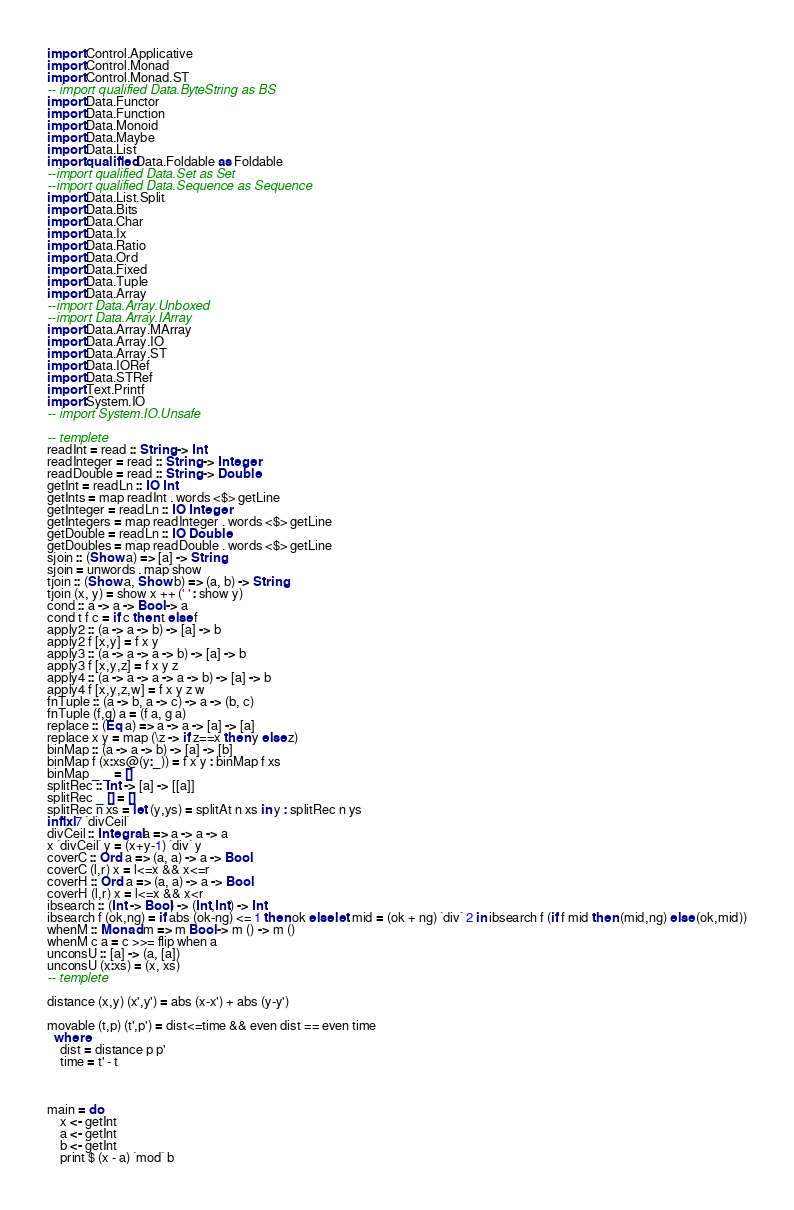<code> <loc_0><loc_0><loc_500><loc_500><_Haskell_>import Control.Applicative
import Control.Monad
import Control.Monad.ST
-- import qualified Data.ByteString as BS
import Data.Functor
import Data.Function
import Data.Monoid
import Data.Maybe
import Data.List
import qualified Data.Foldable as Foldable
--import qualified Data.Set as Set
--import qualified Data.Sequence as Sequence
import Data.List.Split
import Data.Bits
import Data.Char
import Data.Ix
import Data.Ratio
import Data.Ord
import Data.Fixed
import Data.Tuple
import Data.Array
--import Data.Array.Unboxed
--import Data.Array.IArray
import Data.Array.MArray
import Data.Array.IO
import Data.Array.ST
import Data.IORef
import Data.STRef
import Text.Printf
import System.IO
-- import System.IO.Unsafe
 
-- templete
readInt = read :: String -> Int
readInteger = read :: String -> Integer
readDouble = read :: String -> Double
getInt = readLn :: IO Int
getInts = map readInt . words <$> getLine
getInteger = readLn :: IO Integer
getIntegers = map readInteger . words <$> getLine
getDouble = readLn :: IO Double
getDoubles = map readDouble . words <$> getLine
sjoin :: (Show a) => [a] -> String
sjoin = unwords . map show
tjoin :: (Show a, Show b) => (a, b) -> String
tjoin (x, y) = show x ++ (' ' : show y)
cond :: a -> a -> Bool -> a
cond t f c = if c then t else f
apply2 :: (a -> a -> b) -> [a] -> b
apply2 f [x,y] = f x y
apply3 :: (a -> a -> a -> b) -> [a] -> b
apply3 f [x,y,z] = f x y z
apply4 :: (a -> a -> a -> a -> b) -> [a] -> b
apply4 f [x,y,z,w] = f x y z w
fnTuple :: (a -> b, a -> c) -> a -> (b, c)
fnTuple (f,g) a = (f a, g a)
replace :: (Eq a) => a -> a -> [a] -> [a]
replace x y = map (\z -> if z==x then y else z)
binMap :: (a -> a -> b) -> [a] -> [b]
binMap f (x:xs@(y:_)) = f x y : binMap f xs
binMap _ _ = []
splitRec :: Int -> [a] -> [[a]]
splitRec _ [] = []
splitRec n xs = let (y,ys) = splitAt n xs in y : splitRec n ys
infixl 7 `divCeil`
divCeil :: Integral a => a -> a -> a
x `divCeil` y = (x+y-1) `div` y
coverC :: Ord a => (a, a) -> a -> Bool
coverC (l,r) x = l<=x && x<=r
coverH :: Ord a => (a, a) -> a -> Bool
coverH (l,r) x = l<=x && x<r
ibsearch :: (Int -> Bool) -> (Int,Int) -> Int
ibsearch f (ok,ng) = if abs (ok-ng) <= 1 then ok else let mid = (ok + ng) `div` 2 in ibsearch f (if f mid then (mid,ng) else (ok,mid))
whenM :: Monad m => m Bool -> m () -> m ()
whenM c a = c >>= flip when a
unconsU :: [a] -> (a, [a])
unconsU (x:xs) = (x, xs)
-- templete

distance (x,y) (x',y') = abs (x-x') + abs (y-y')

movable (t,p) (t',p') = dist<=time && even dist == even time
  where
    dist = distance p p'
    time = t' - t



main = do
    x <- getInt
    a <- getInt
    b <- getInt
    print $ (x - a) `mod` b</code> 